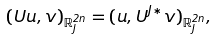Convert formula to latex. <formula><loc_0><loc_0><loc_500><loc_500>( U u , v ) _ { \mathbb { R } ^ { 2 n } _ { J } } = ( u , U ^ { J * } v ) _ { \mathbb { R } ^ { 2 n } _ { J } } ,</formula> 